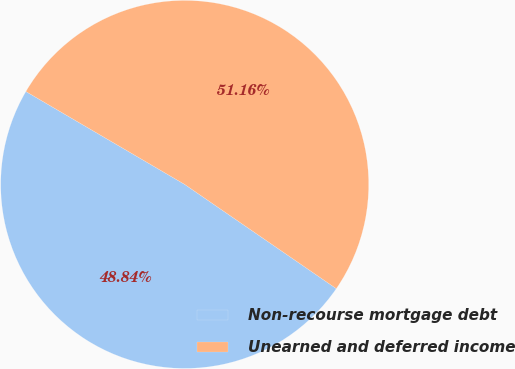<chart> <loc_0><loc_0><loc_500><loc_500><pie_chart><fcel>Non-recourse mortgage debt<fcel>Unearned and deferred income<nl><fcel>48.84%<fcel>51.16%<nl></chart> 